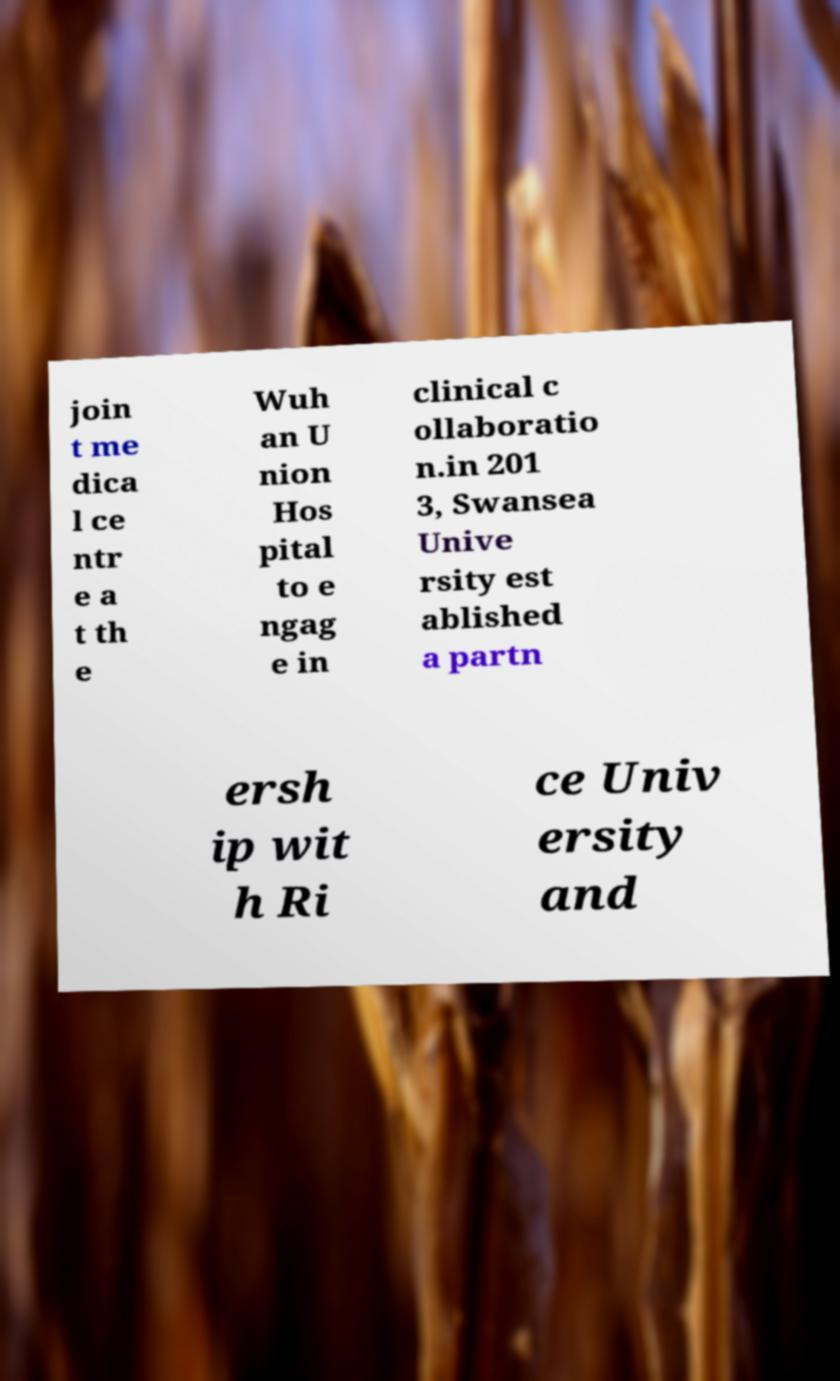Can you accurately transcribe the text from the provided image for me? join t me dica l ce ntr e a t th e Wuh an U nion Hos pital to e ngag e in clinical c ollaboratio n.in 201 3, Swansea Unive rsity est ablished a partn ersh ip wit h Ri ce Univ ersity and 